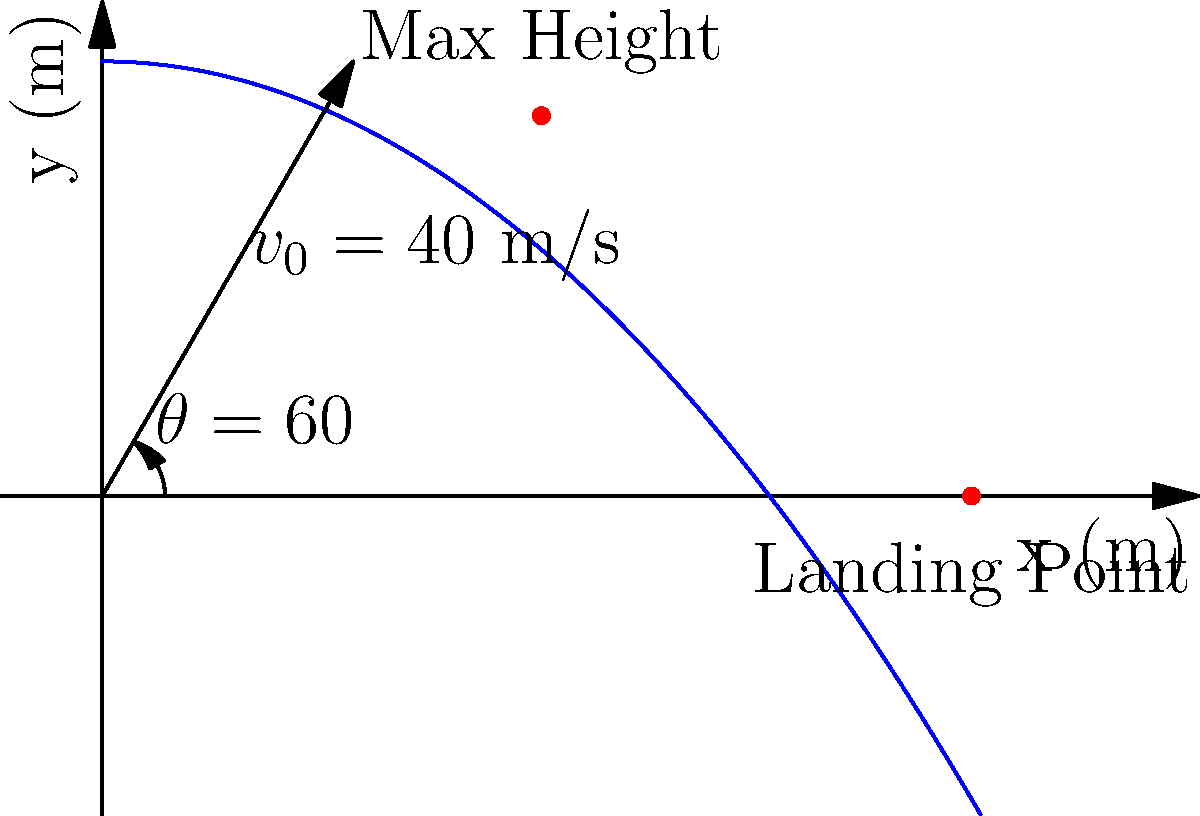In a physics-based AI simulation, you're tasked with calculating the trajectory of a projectile launched from ground level. The projectile is fired with an initial velocity ($v_0$) of 40 m/s at an angle ($\theta$) of 60° to the horizontal. Assuming no air resistance and using $g = 9.8$ m/s² for acceleration due to gravity, determine:

a) The maximum height reached by the projectile
b) The time taken to reach the maximum height
c) The total time of flight
d) The horizontal distance traveled (range)

Round your answers to two decimal places. Let's solve this step-by-step using trigonometry and projectile motion equations:

1) First, let's break down the initial velocity into its components:
   $v_{0x} = v_0 \cos(\theta) = 40 \cos(60°) = 20$ m/s
   $v_{0y} = v_0 \sin(\theta) = 40 \sin(60°) = 34.64$ m/s

2) Maximum height (h):
   At the highest point, $v_y = 0$
   Using $v_y^2 = v_{0y}^2 - 2gh$, we get:
   $0 = 34.64^2 - 2(9.8)h$
   $h = \frac{34.64^2}{2(9.8)} = 30.31$ m

3) Time to reach maximum height ($t_{max}$):
   Using $v_y = v_{0y} - gt$, we get:
   $0 = 34.64 - 9.8t_{max}$
   $t_{max} = \frac{34.64}{9.8} = 3.53$ s

4) Total time of flight ($t_{total}$):
   The time to fall back to the ground is equal to the time to reach max height.
   So, $t_{total} = 2t_{max} = 2(3.53) = 7.06$ s

5) Horizontal distance (range, R):
   $R = v_{0x} * t_{total} = 20 * 7.06 = 141.20$ m

Therefore:
a) Maximum height = 30.31 m
b) Time to reach maximum height = 3.53 s
c) Total time of flight = 7.06 s
d) Horizontal distance traveled = 141.20 m
Answer: a) 30.31 m
b) 3.53 s
c) 7.06 s
d) 141.20 m 